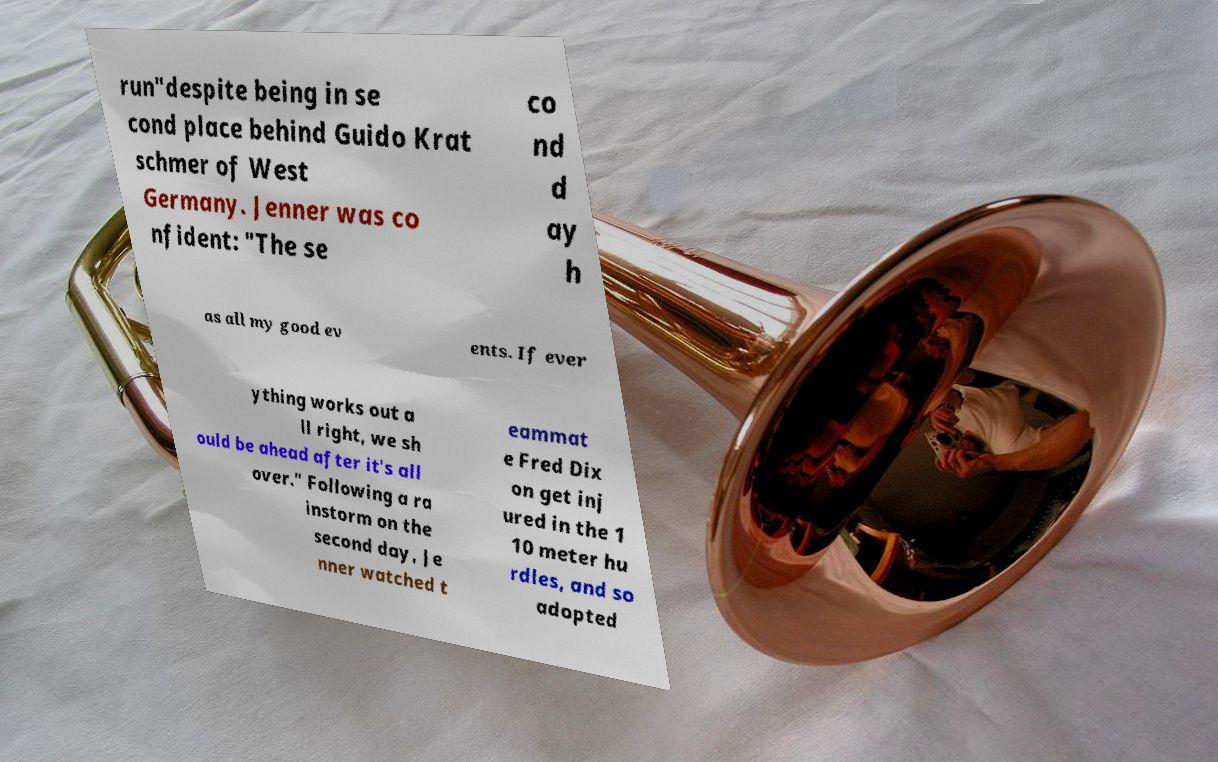For documentation purposes, I need the text within this image transcribed. Could you provide that? run"despite being in se cond place behind Guido Krat schmer of West Germany. Jenner was co nfident: "The se co nd d ay h as all my good ev ents. If ever ything works out a ll right, we sh ould be ahead after it's all over." Following a ra instorm on the second day, Je nner watched t eammat e Fred Dix on get inj ured in the 1 10 meter hu rdles, and so adopted 